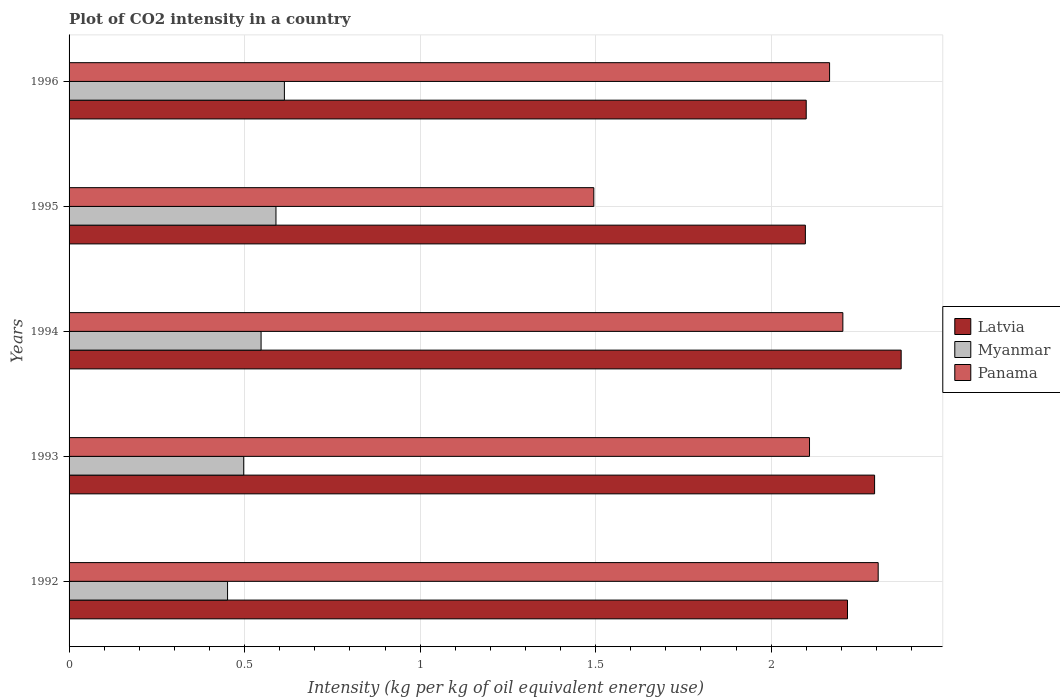How many different coloured bars are there?
Ensure brevity in your answer.  3. How many bars are there on the 5th tick from the top?
Make the answer very short. 3. How many bars are there on the 5th tick from the bottom?
Provide a succinct answer. 3. What is the CO2 intensity in in Myanmar in 1994?
Ensure brevity in your answer.  0.55. Across all years, what is the maximum CO2 intensity in in Panama?
Provide a succinct answer. 2.3. Across all years, what is the minimum CO2 intensity in in Latvia?
Offer a very short reply. 2.1. In which year was the CO2 intensity in in Latvia maximum?
Your answer should be very brief. 1994. What is the total CO2 intensity in in Latvia in the graph?
Ensure brevity in your answer.  11.08. What is the difference between the CO2 intensity in in Myanmar in 1993 and that in 1996?
Provide a succinct answer. -0.12. What is the difference between the CO2 intensity in in Latvia in 1992 and the CO2 intensity in in Myanmar in 1996?
Offer a terse response. 1.6. What is the average CO2 intensity in in Myanmar per year?
Keep it short and to the point. 0.54. In the year 1993, what is the difference between the CO2 intensity in in Panama and CO2 intensity in in Latvia?
Give a very brief answer. -0.19. What is the ratio of the CO2 intensity in in Panama in 1994 to that in 1995?
Offer a very short reply. 1.47. Is the difference between the CO2 intensity in in Panama in 1993 and 1996 greater than the difference between the CO2 intensity in in Latvia in 1993 and 1996?
Your answer should be compact. No. What is the difference between the highest and the second highest CO2 intensity in in Latvia?
Provide a succinct answer. 0.08. What is the difference between the highest and the lowest CO2 intensity in in Latvia?
Offer a terse response. 0.27. What does the 1st bar from the top in 1992 represents?
Provide a short and direct response. Panama. What does the 1st bar from the bottom in 1996 represents?
Give a very brief answer. Latvia. How many bars are there?
Give a very brief answer. 15. How many legend labels are there?
Your response must be concise. 3. What is the title of the graph?
Your response must be concise. Plot of CO2 intensity in a country. Does "Small states" appear as one of the legend labels in the graph?
Make the answer very short. No. What is the label or title of the X-axis?
Provide a short and direct response. Intensity (kg per kg of oil equivalent energy use). What is the Intensity (kg per kg of oil equivalent energy use) in Latvia in 1992?
Make the answer very short. 2.22. What is the Intensity (kg per kg of oil equivalent energy use) of Myanmar in 1992?
Your answer should be compact. 0.45. What is the Intensity (kg per kg of oil equivalent energy use) of Panama in 1992?
Offer a terse response. 2.3. What is the Intensity (kg per kg of oil equivalent energy use) in Latvia in 1993?
Offer a terse response. 2.29. What is the Intensity (kg per kg of oil equivalent energy use) in Myanmar in 1993?
Provide a short and direct response. 0.5. What is the Intensity (kg per kg of oil equivalent energy use) of Panama in 1993?
Offer a terse response. 2.11. What is the Intensity (kg per kg of oil equivalent energy use) of Latvia in 1994?
Your answer should be compact. 2.37. What is the Intensity (kg per kg of oil equivalent energy use) of Myanmar in 1994?
Offer a very short reply. 0.55. What is the Intensity (kg per kg of oil equivalent energy use) in Panama in 1994?
Offer a terse response. 2.2. What is the Intensity (kg per kg of oil equivalent energy use) of Latvia in 1995?
Give a very brief answer. 2.1. What is the Intensity (kg per kg of oil equivalent energy use) in Myanmar in 1995?
Provide a short and direct response. 0.59. What is the Intensity (kg per kg of oil equivalent energy use) in Panama in 1995?
Keep it short and to the point. 1.49. What is the Intensity (kg per kg of oil equivalent energy use) in Latvia in 1996?
Your answer should be compact. 2.1. What is the Intensity (kg per kg of oil equivalent energy use) of Myanmar in 1996?
Make the answer very short. 0.61. What is the Intensity (kg per kg of oil equivalent energy use) in Panama in 1996?
Offer a terse response. 2.17. Across all years, what is the maximum Intensity (kg per kg of oil equivalent energy use) in Latvia?
Offer a terse response. 2.37. Across all years, what is the maximum Intensity (kg per kg of oil equivalent energy use) of Myanmar?
Keep it short and to the point. 0.61. Across all years, what is the maximum Intensity (kg per kg of oil equivalent energy use) in Panama?
Your response must be concise. 2.3. Across all years, what is the minimum Intensity (kg per kg of oil equivalent energy use) of Latvia?
Ensure brevity in your answer.  2.1. Across all years, what is the minimum Intensity (kg per kg of oil equivalent energy use) in Myanmar?
Ensure brevity in your answer.  0.45. Across all years, what is the minimum Intensity (kg per kg of oil equivalent energy use) of Panama?
Your answer should be compact. 1.49. What is the total Intensity (kg per kg of oil equivalent energy use) of Latvia in the graph?
Ensure brevity in your answer.  11.08. What is the total Intensity (kg per kg of oil equivalent energy use) in Myanmar in the graph?
Ensure brevity in your answer.  2.7. What is the total Intensity (kg per kg of oil equivalent energy use) of Panama in the graph?
Offer a very short reply. 10.28. What is the difference between the Intensity (kg per kg of oil equivalent energy use) in Latvia in 1992 and that in 1993?
Keep it short and to the point. -0.08. What is the difference between the Intensity (kg per kg of oil equivalent energy use) in Myanmar in 1992 and that in 1993?
Ensure brevity in your answer.  -0.05. What is the difference between the Intensity (kg per kg of oil equivalent energy use) of Panama in 1992 and that in 1993?
Offer a very short reply. 0.2. What is the difference between the Intensity (kg per kg of oil equivalent energy use) in Latvia in 1992 and that in 1994?
Provide a short and direct response. -0.15. What is the difference between the Intensity (kg per kg of oil equivalent energy use) of Myanmar in 1992 and that in 1994?
Provide a short and direct response. -0.1. What is the difference between the Intensity (kg per kg of oil equivalent energy use) of Panama in 1992 and that in 1994?
Give a very brief answer. 0.1. What is the difference between the Intensity (kg per kg of oil equivalent energy use) of Latvia in 1992 and that in 1995?
Give a very brief answer. 0.12. What is the difference between the Intensity (kg per kg of oil equivalent energy use) in Myanmar in 1992 and that in 1995?
Offer a terse response. -0.14. What is the difference between the Intensity (kg per kg of oil equivalent energy use) of Panama in 1992 and that in 1995?
Keep it short and to the point. 0.81. What is the difference between the Intensity (kg per kg of oil equivalent energy use) of Latvia in 1992 and that in 1996?
Offer a very short reply. 0.12. What is the difference between the Intensity (kg per kg of oil equivalent energy use) in Myanmar in 1992 and that in 1996?
Provide a short and direct response. -0.16. What is the difference between the Intensity (kg per kg of oil equivalent energy use) of Panama in 1992 and that in 1996?
Your answer should be compact. 0.14. What is the difference between the Intensity (kg per kg of oil equivalent energy use) of Latvia in 1993 and that in 1994?
Offer a terse response. -0.08. What is the difference between the Intensity (kg per kg of oil equivalent energy use) of Myanmar in 1993 and that in 1994?
Ensure brevity in your answer.  -0.05. What is the difference between the Intensity (kg per kg of oil equivalent energy use) in Panama in 1993 and that in 1994?
Give a very brief answer. -0.1. What is the difference between the Intensity (kg per kg of oil equivalent energy use) in Latvia in 1993 and that in 1995?
Provide a succinct answer. 0.2. What is the difference between the Intensity (kg per kg of oil equivalent energy use) of Myanmar in 1993 and that in 1995?
Offer a terse response. -0.09. What is the difference between the Intensity (kg per kg of oil equivalent energy use) of Panama in 1993 and that in 1995?
Offer a terse response. 0.61. What is the difference between the Intensity (kg per kg of oil equivalent energy use) in Latvia in 1993 and that in 1996?
Ensure brevity in your answer.  0.19. What is the difference between the Intensity (kg per kg of oil equivalent energy use) in Myanmar in 1993 and that in 1996?
Your response must be concise. -0.12. What is the difference between the Intensity (kg per kg of oil equivalent energy use) in Panama in 1993 and that in 1996?
Offer a very short reply. -0.06. What is the difference between the Intensity (kg per kg of oil equivalent energy use) of Latvia in 1994 and that in 1995?
Make the answer very short. 0.27. What is the difference between the Intensity (kg per kg of oil equivalent energy use) in Myanmar in 1994 and that in 1995?
Provide a succinct answer. -0.04. What is the difference between the Intensity (kg per kg of oil equivalent energy use) of Panama in 1994 and that in 1995?
Offer a terse response. 0.71. What is the difference between the Intensity (kg per kg of oil equivalent energy use) in Latvia in 1994 and that in 1996?
Your answer should be compact. 0.27. What is the difference between the Intensity (kg per kg of oil equivalent energy use) in Myanmar in 1994 and that in 1996?
Offer a terse response. -0.07. What is the difference between the Intensity (kg per kg of oil equivalent energy use) of Panama in 1994 and that in 1996?
Offer a terse response. 0.04. What is the difference between the Intensity (kg per kg of oil equivalent energy use) in Latvia in 1995 and that in 1996?
Ensure brevity in your answer.  -0. What is the difference between the Intensity (kg per kg of oil equivalent energy use) of Myanmar in 1995 and that in 1996?
Provide a short and direct response. -0.02. What is the difference between the Intensity (kg per kg of oil equivalent energy use) in Panama in 1995 and that in 1996?
Offer a terse response. -0.67. What is the difference between the Intensity (kg per kg of oil equivalent energy use) of Latvia in 1992 and the Intensity (kg per kg of oil equivalent energy use) of Myanmar in 1993?
Your response must be concise. 1.72. What is the difference between the Intensity (kg per kg of oil equivalent energy use) in Latvia in 1992 and the Intensity (kg per kg of oil equivalent energy use) in Panama in 1993?
Provide a succinct answer. 0.11. What is the difference between the Intensity (kg per kg of oil equivalent energy use) of Myanmar in 1992 and the Intensity (kg per kg of oil equivalent energy use) of Panama in 1993?
Ensure brevity in your answer.  -1.66. What is the difference between the Intensity (kg per kg of oil equivalent energy use) in Latvia in 1992 and the Intensity (kg per kg of oil equivalent energy use) in Myanmar in 1994?
Provide a short and direct response. 1.67. What is the difference between the Intensity (kg per kg of oil equivalent energy use) in Latvia in 1992 and the Intensity (kg per kg of oil equivalent energy use) in Panama in 1994?
Provide a succinct answer. 0.01. What is the difference between the Intensity (kg per kg of oil equivalent energy use) of Myanmar in 1992 and the Intensity (kg per kg of oil equivalent energy use) of Panama in 1994?
Your answer should be compact. -1.75. What is the difference between the Intensity (kg per kg of oil equivalent energy use) of Latvia in 1992 and the Intensity (kg per kg of oil equivalent energy use) of Myanmar in 1995?
Give a very brief answer. 1.63. What is the difference between the Intensity (kg per kg of oil equivalent energy use) of Latvia in 1992 and the Intensity (kg per kg of oil equivalent energy use) of Panama in 1995?
Offer a very short reply. 0.72. What is the difference between the Intensity (kg per kg of oil equivalent energy use) in Myanmar in 1992 and the Intensity (kg per kg of oil equivalent energy use) in Panama in 1995?
Provide a short and direct response. -1.04. What is the difference between the Intensity (kg per kg of oil equivalent energy use) of Latvia in 1992 and the Intensity (kg per kg of oil equivalent energy use) of Myanmar in 1996?
Offer a terse response. 1.6. What is the difference between the Intensity (kg per kg of oil equivalent energy use) of Latvia in 1992 and the Intensity (kg per kg of oil equivalent energy use) of Panama in 1996?
Your response must be concise. 0.05. What is the difference between the Intensity (kg per kg of oil equivalent energy use) in Myanmar in 1992 and the Intensity (kg per kg of oil equivalent energy use) in Panama in 1996?
Your answer should be compact. -1.71. What is the difference between the Intensity (kg per kg of oil equivalent energy use) in Latvia in 1993 and the Intensity (kg per kg of oil equivalent energy use) in Myanmar in 1994?
Provide a short and direct response. 1.75. What is the difference between the Intensity (kg per kg of oil equivalent energy use) of Latvia in 1993 and the Intensity (kg per kg of oil equivalent energy use) of Panama in 1994?
Make the answer very short. 0.09. What is the difference between the Intensity (kg per kg of oil equivalent energy use) in Myanmar in 1993 and the Intensity (kg per kg of oil equivalent energy use) in Panama in 1994?
Provide a short and direct response. -1.71. What is the difference between the Intensity (kg per kg of oil equivalent energy use) in Latvia in 1993 and the Intensity (kg per kg of oil equivalent energy use) in Myanmar in 1995?
Your answer should be compact. 1.71. What is the difference between the Intensity (kg per kg of oil equivalent energy use) in Latvia in 1993 and the Intensity (kg per kg of oil equivalent energy use) in Panama in 1995?
Keep it short and to the point. 0.8. What is the difference between the Intensity (kg per kg of oil equivalent energy use) in Myanmar in 1993 and the Intensity (kg per kg of oil equivalent energy use) in Panama in 1995?
Make the answer very short. -1. What is the difference between the Intensity (kg per kg of oil equivalent energy use) in Latvia in 1993 and the Intensity (kg per kg of oil equivalent energy use) in Myanmar in 1996?
Provide a succinct answer. 1.68. What is the difference between the Intensity (kg per kg of oil equivalent energy use) of Latvia in 1993 and the Intensity (kg per kg of oil equivalent energy use) of Panama in 1996?
Offer a terse response. 0.13. What is the difference between the Intensity (kg per kg of oil equivalent energy use) of Myanmar in 1993 and the Intensity (kg per kg of oil equivalent energy use) of Panama in 1996?
Offer a terse response. -1.67. What is the difference between the Intensity (kg per kg of oil equivalent energy use) in Latvia in 1994 and the Intensity (kg per kg of oil equivalent energy use) in Myanmar in 1995?
Offer a terse response. 1.78. What is the difference between the Intensity (kg per kg of oil equivalent energy use) in Latvia in 1994 and the Intensity (kg per kg of oil equivalent energy use) in Panama in 1995?
Your answer should be very brief. 0.88. What is the difference between the Intensity (kg per kg of oil equivalent energy use) in Myanmar in 1994 and the Intensity (kg per kg of oil equivalent energy use) in Panama in 1995?
Offer a very short reply. -0.95. What is the difference between the Intensity (kg per kg of oil equivalent energy use) in Latvia in 1994 and the Intensity (kg per kg of oil equivalent energy use) in Myanmar in 1996?
Provide a succinct answer. 1.76. What is the difference between the Intensity (kg per kg of oil equivalent energy use) of Latvia in 1994 and the Intensity (kg per kg of oil equivalent energy use) of Panama in 1996?
Give a very brief answer. 0.2. What is the difference between the Intensity (kg per kg of oil equivalent energy use) of Myanmar in 1994 and the Intensity (kg per kg of oil equivalent energy use) of Panama in 1996?
Your answer should be compact. -1.62. What is the difference between the Intensity (kg per kg of oil equivalent energy use) in Latvia in 1995 and the Intensity (kg per kg of oil equivalent energy use) in Myanmar in 1996?
Offer a terse response. 1.48. What is the difference between the Intensity (kg per kg of oil equivalent energy use) in Latvia in 1995 and the Intensity (kg per kg of oil equivalent energy use) in Panama in 1996?
Your answer should be very brief. -0.07. What is the difference between the Intensity (kg per kg of oil equivalent energy use) in Myanmar in 1995 and the Intensity (kg per kg of oil equivalent energy use) in Panama in 1996?
Make the answer very short. -1.58. What is the average Intensity (kg per kg of oil equivalent energy use) of Latvia per year?
Ensure brevity in your answer.  2.22. What is the average Intensity (kg per kg of oil equivalent energy use) of Myanmar per year?
Offer a terse response. 0.54. What is the average Intensity (kg per kg of oil equivalent energy use) of Panama per year?
Offer a terse response. 2.06. In the year 1992, what is the difference between the Intensity (kg per kg of oil equivalent energy use) of Latvia and Intensity (kg per kg of oil equivalent energy use) of Myanmar?
Your answer should be compact. 1.77. In the year 1992, what is the difference between the Intensity (kg per kg of oil equivalent energy use) in Latvia and Intensity (kg per kg of oil equivalent energy use) in Panama?
Your answer should be compact. -0.09. In the year 1992, what is the difference between the Intensity (kg per kg of oil equivalent energy use) of Myanmar and Intensity (kg per kg of oil equivalent energy use) of Panama?
Make the answer very short. -1.85. In the year 1993, what is the difference between the Intensity (kg per kg of oil equivalent energy use) in Latvia and Intensity (kg per kg of oil equivalent energy use) in Myanmar?
Your response must be concise. 1.8. In the year 1993, what is the difference between the Intensity (kg per kg of oil equivalent energy use) in Latvia and Intensity (kg per kg of oil equivalent energy use) in Panama?
Offer a very short reply. 0.19. In the year 1993, what is the difference between the Intensity (kg per kg of oil equivalent energy use) in Myanmar and Intensity (kg per kg of oil equivalent energy use) in Panama?
Your response must be concise. -1.61. In the year 1994, what is the difference between the Intensity (kg per kg of oil equivalent energy use) of Latvia and Intensity (kg per kg of oil equivalent energy use) of Myanmar?
Your answer should be very brief. 1.82. In the year 1994, what is the difference between the Intensity (kg per kg of oil equivalent energy use) in Latvia and Intensity (kg per kg of oil equivalent energy use) in Panama?
Your answer should be compact. 0.17. In the year 1994, what is the difference between the Intensity (kg per kg of oil equivalent energy use) in Myanmar and Intensity (kg per kg of oil equivalent energy use) in Panama?
Offer a terse response. -1.66. In the year 1995, what is the difference between the Intensity (kg per kg of oil equivalent energy use) of Latvia and Intensity (kg per kg of oil equivalent energy use) of Myanmar?
Provide a short and direct response. 1.51. In the year 1995, what is the difference between the Intensity (kg per kg of oil equivalent energy use) in Latvia and Intensity (kg per kg of oil equivalent energy use) in Panama?
Your answer should be compact. 0.6. In the year 1995, what is the difference between the Intensity (kg per kg of oil equivalent energy use) in Myanmar and Intensity (kg per kg of oil equivalent energy use) in Panama?
Give a very brief answer. -0.91. In the year 1996, what is the difference between the Intensity (kg per kg of oil equivalent energy use) in Latvia and Intensity (kg per kg of oil equivalent energy use) in Myanmar?
Your answer should be very brief. 1.49. In the year 1996, what is the difference between the Intensity (kg per kg of oil equivalent energy use) of Latvia and Intensity (kg per kg of oil equivalent energy use) of Panama?
Your answer should be very brief. -0.07. In the year 1996, what is the difference between the Intensity (kg per kg of oil equivalent energy use) in Myanmar and Intensity (kg per kg of oil equivalent energy use) in Panama?
Make the answer very short. -1.55. What is the ratio of the Intensity (kg per kg of oil equivalent energy use) in Latvia in 1992 to that in 1993?
Offer a terse response. 0.97. What is the ratio of the Intensity (kg per kg of oil equivalent energy use) in Myanmar in 1992 to that in 1993?
Keep it short and to the point. 0.91. What is the ratio of the Intensity (kg per kg of oil equivalent energy use) in Panama in 1992 to that in 1993?
Offer a very short reply. 1.09. What is the ratio of the Intensity (kg per kg of oil equivalent energy use) in Latvia in 1992 to that in 1994?
Your answer should be very brief. 0.94. What is the ratio of the Intensity (kg per kg of oil equivalent energy use) of Myanmar in 1992 to that in 1994?
Provide a short and direct response. 0.83. What is the ratio of the Intensity (kg per kg of oil equivalent energy use) of Panama in 1992 to that in 1994?
Make the answer very short. 1.05. What is the ratio of the Intensity (kg per kg of oil equivalent energy use) of Latvia in 1992 to that in 1995?
Give a very brief answer. 1.06. What is the ratio of the Intensity (kg per kg of oil equivalent energy use) in Myanmar in 1992 to that in 1995?
Provide a succinct answer. 0.77. What is the ratio of the Intensity (kg per kg of oil equivalent energy use) in Panama in 1992 to that in 1995?
Provide a short and direct response. 1.54. What is the ratio of the Intensity (kg per kg of oil equivalent energy use) in Latvia in 1992 to that in 1996?
Offer a terse response. 1.06. What is the ratio of the Intensity (kg per kg of oil equivalent energy use) of Myanmar in 1992 to that in 1996?
Your answer should be very brief. 0.74. What is the ratio of the Intensity (kg per kg of oil equivalent energy use) of Panama in 1992 to that in 1996?
Make the answer very short. 1.06. What is the ratio of the Intensity (kg per kg of oil equivalent energy use) of Latvia in 1993 to that in 1994?
Offer a terse response. 0.97. What is the ratio of the Intensity (kg per kg of oil equivalent energy use) in Myanmar in 1993 to that in 1994?
Your response must be concise. 0.91. What is the ratio of the Intensity (kg per kg of oil equivalent energy use) of Panama in 1993 to that in 1994?
Offer a terse response. 0.96. What is the ratio of the Intensity (kg per kg of oil equivalent energy use) of Latvia in 1993 to that in 1995?
Provide a short and direct response. 1.09. What is the ratio of the Intensity (kg per kg of oil equivalent energy use) of Myanmar in 1993 to that in 1995?
Your response must be concise. 0.84. What is the ratio of the Intensity (kg per kg of oil equivalent energy use) in Panama in 1993 to that in 1995?
Offer a very short reply. 1.41. What is the ratio of the Intensity (kg per kg of oil equivalent energy use) in Latvia in 1993 to that in 1996?
Your response must be concise. 1.09. What is the ratio of the Intensity (kg per kg of oil equivalent energy use) in Myanmar in 1993 to that in 1996?
Offer a very short reply. 0.81. What is the ratio of the Intensity (kg per kg of oil equivalent energy use) in Panama in 1993 to that in 1996?
Ensure brevity in your answer.  0.97. What is the ratio of the Intensity (kg per kg of oil equivalent energy use) of Latvia in 1994 to that in 1995?
Your response must be concise. 1.13. What is the ratio of the Intensity (kg per kg of oil equivalent energy use) in Myanmar in 1994 to that in 1995?
Keep it short and to the point. 0.93. What is the ratio of the Intensity (kg per kg of oil equivalent energy use) of Panama in 1994 to that in 1995?
Make the answer very short. 1.47. What is the ratio of the Intensity (kg per kg of oil equivalent energy use) in Latvia in 1994 to that in 1996?
Provide a succinct answer. 1.13. What is the ratio of the Intensity (kg per kg of oil equivalent energy use) of Myanmar in 1994 to that in 1996?
Offer a very short reply. 0.89. What is the ratio of the Intensity (kg per kg of oil equivalent energy use) of Panama in 1994 to that in 1996?
Make the answer very short. 1.02. What is the ratio of the Intensity (kg per kg of oil equivalent energy use) of Myanmar in 1995 to that in 1996?
Provide a short and direct response. 0.96. What is the ratio of the Intensity (kg per kg of oil equivalent energy use) of Panama in 1995 to that in 1996?
Give a very brief answer. 0.69. What is the difference between the highest and the second highest Intensity (kg per kg of oil equivalent energy use) in Latvia?
Offer a very short reply. 0.08. What is the difference between the highest and the second highest Intensity (kg per kg of oil equivalent energy use) in Myanmar?
Provide a short and direct response. 0.02. What is the difference between the highest and the second highest Intensity (kg per kg of oil equivalent energy use) of Panama?
Your answer should be compact. 0.1. What is the difference between the highest and the lowest Intensity (kg per kg of oil equivalent energy use) in Latvia?
Provide a short and direct response. 0.27. What is the difference between the highest and the lowest Intensity (kg per kg of oil equivalent energy use) of Myanmar?
Offer a terse response. 0.16. What is the difference between the highest and the lowest Intensity (kg per kg of oil equivalent energy use) in Panama?
Make the answer very short. 0.81. 